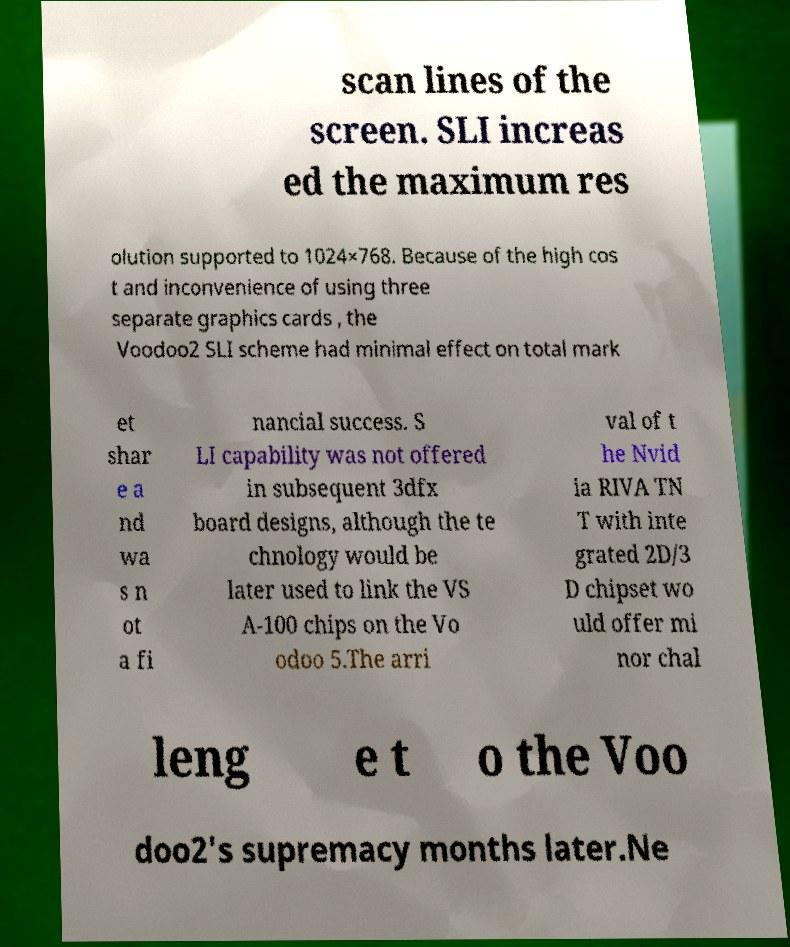Could you assist in decoding the text presented in this image and type it out clearly? scan lines of the screen. SLI increas ed the maximum res olution supported to 1024×768. Because of the high cos t and inconvenience of using three separate graphics cards , the Voodoo2 SLI scheme had minimal effect on total mark et shar e a nd wa s n ot a fi nancial success. S LI capability was not offered in subsequent 3dfx board designs, although the te chnology would be later used to link the VS A-100 chips on the Vo odoo 5.The arri val of t he Nvid ia RIVA TN T with inte grated 2D/3 D chipset wo uld offer mi nor chal leng e t o the Voo doo2's supremacy months later.Ne 